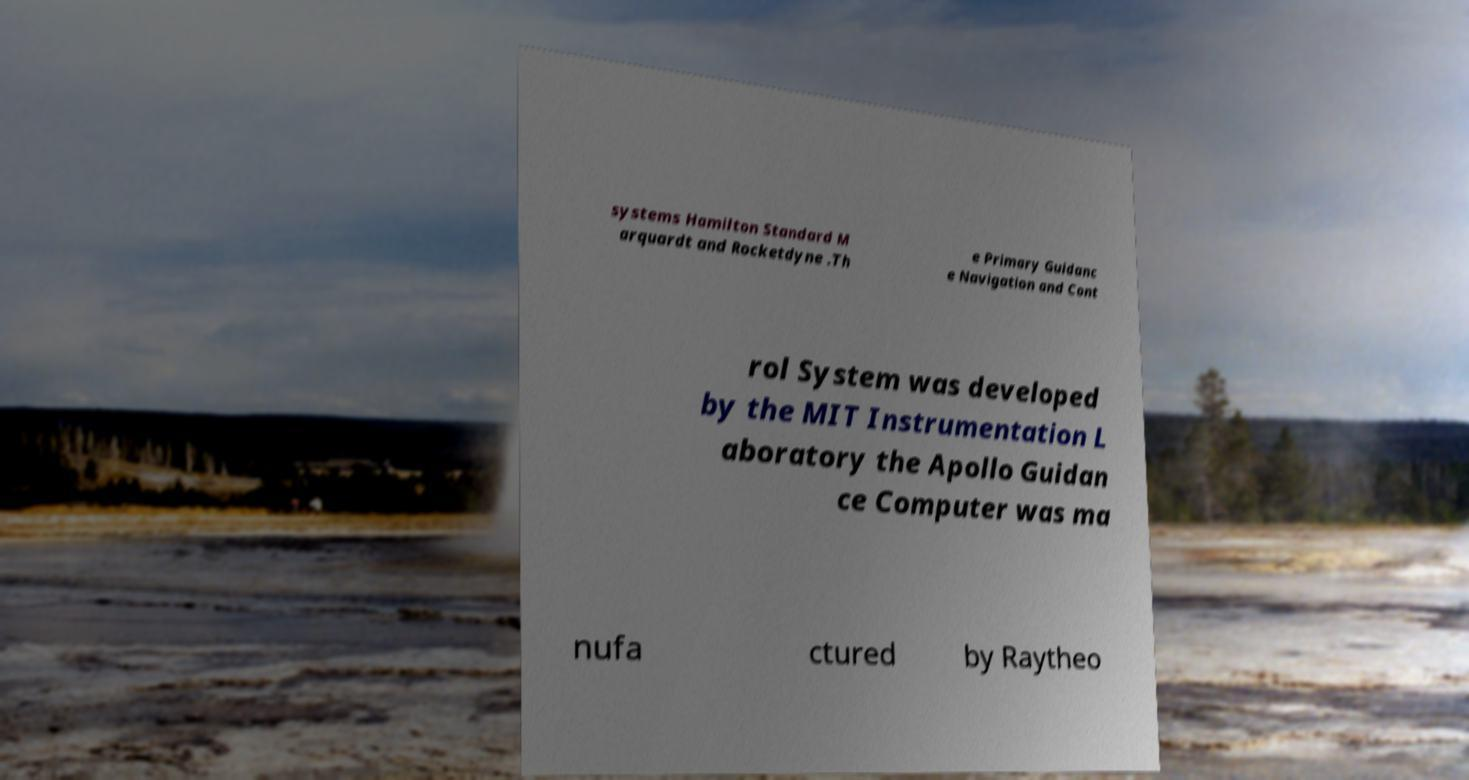I need the written content from this picture converted into text. Can you do that? systems Hamilton Standard M arquardt and Rocketdyne .Th e Primary Guidanc e Navigation and Cont rol System was developed by the MIT Instrumentation L aboratory the Apollo Guidan ce Computer was ma nufa ctured by Raytheo 